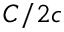<formula> <loc_0><loc_0><loc_500><loc_500>C / 2 c</formula> 